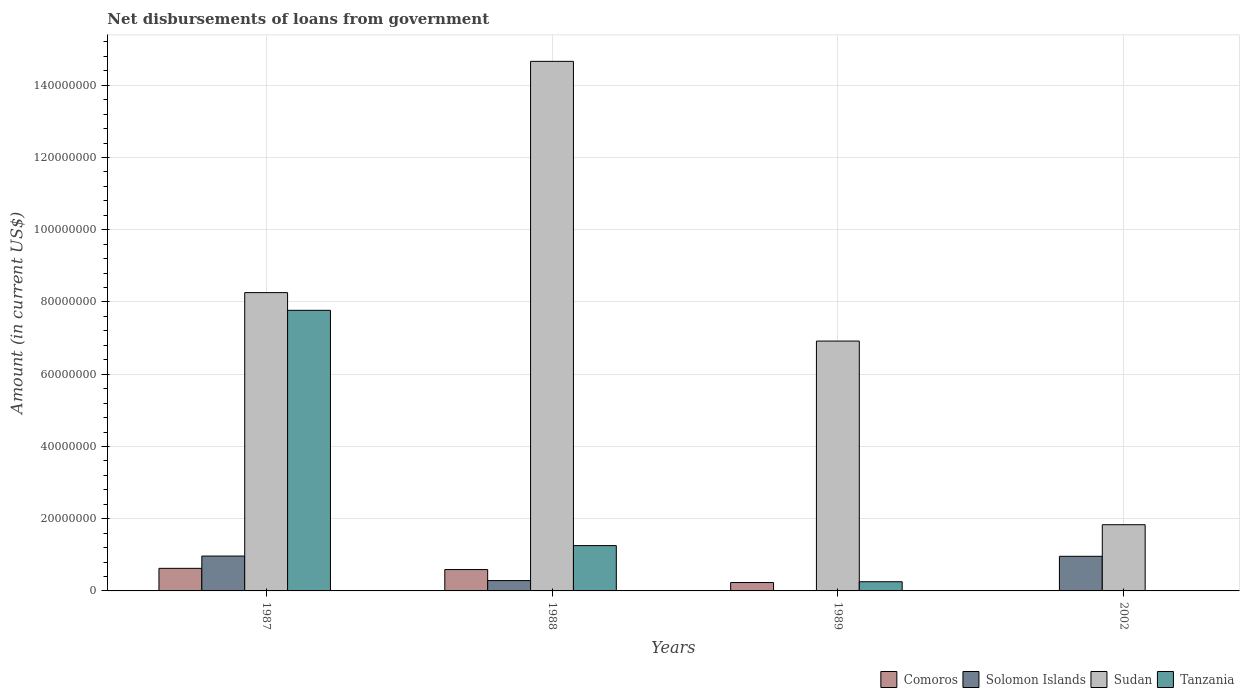How many different coloured bars are there?
Provide a succinct answer. 4. Are the number of bars on each tick of the X-axis equal?
Ensure brevity in your answer.  No. In how many cases, is the number of bars for a given year not equal to the number of legend labels?
Ensure brevity in your answer.  2. What is the amount of loan disbursed from government in Sudan in 1989?
Your answer should be compact. 6.92e+07. Across all years, what is the maximum amount of loan disbursed from government in Solomon Islands?
Give a very brief answer. 9.65e+06. Across all years, what is the minimum amount of loan disbursed from government in Tanzania?
Give a very brief answer. 0. In which year was the amount of loan disbursed from government in Sudan maximum?
Offer a very short reply. 1988. What is the total amount of loan disbursed from government in Comoros in the graph?
Give a very brief answer. 1.45e+07. What is the difference between the amount of loan disbursed from government in Sudan in 1987 and that in 1988?
Your response must be concise. -6.40e+07. What is the difference between the amount of loan disbursed from government in Sudan in 1987 and the amount of loan disbursed from government in Solomon Islands in 2002?
Give a very brief answer. 7.30e+07. What is the average amount of loan disbursed from government in Comoros per year?
Offer a very short reply. 3.62e+06. In the year 1987, what is the difference between the amount of loan disbursed from government in Comoros and amount of loan disbursed from government in Solomon Islands?
Make the answer very short. -3.40e+06. In how many years, is the amount of loan disbursed from government in Solomon Islands greater than 112000000 US$?
Give a very brief answer. 0. What is the ratio of the amount of loan disbursed from government in Tanzania in 1987 to that in 1989?
Your answer should be compact. 30.58. What is the difference between the highest and the second highest amount of loan disbursed from government in Sudan?
Make the answer very short. 6.40e+07. What is the difference between the highest and the lowest amount of loan disbursed from government in Tanzania?
Provide a succinct answer. 7.77e+07. In how many years, is the amount of loan disbursed from government in Tanzania greater than the average amount of loan disbursed from government in Tanzania taken over all years?
Offer a very short reply. 1. Is it the case that in every year, the sum of the amount of loan disbursed from government in Tanzania and amount of loan disbursed from government in Sudan is greater than the sum of amount of loan disbursed from government in Solomon Islands and amount of loan disbursed from government in Comoros?
Give a very brief answer. Yes. What is the difference between two consecutive major ticks on the Y-axis?
Offer a terse response. 2.00e+07. Where does the legend appear in the graph?
Provide a succinct answer. Bottom right. How are the legend labels stacked?
Give a very brief answer. Horizontal. What is the title of the graph?
Ensure brevity in your answer.  Net disbursements of loans from government. Does "United Arab Emirates" appear as one of the legend labels in the graph?
Provide a succinct answer. No. What is the label or title of the Y-axis?
Give a very brief answer. Amount (in current US$). What is the Amount (in current US$) in Comoros in 1987?
Your answer should be very brief. 6.25e+06. What is the Amount (in current US$) of Solomon Islands in 1987?
Your answer should be very brief. 9.65e+06. What is the Amount (in current US$) of Sudan in 1987?
Your response must be concise. 8.26e+07. What is the Amount (in current US$) of Tanzania in 1987?
Make the answer very short. 7.77e+07. What is the Amount (in current US$) in Comoros in 1988?
Provide a succinct answer. 5.91e+06. What is the Amount (in current US$) of Solomon Islands in 1988?
Offer a very short reply. 2.86e+06. What is the Amount (in current US$) in Sudan in 1988?
Provide a succinct answer. 1.47e+08. What is the Amount (in current US$) of Tanzania in 1988?
Offer a very short reply. 1.25e+07. What is the Amount (in current US$) in Comoros in 1989?
Give a very brief answer. 2.32e+06. What is the Amount (in current US$) in Sudan in 1989?
Offer a very short reply. 6.92e+07. What is the Amount (in current US$) of Tanzania in 1989?
Your answer should be very brief. 2.54e+06. What is the Amount (in current US$) of Comoros in 2002?
Offer a very short reply. 0. What is the Amount (in current US$) in Solomon Islands in 2002?
Keep it short and to the point. 9.58e+06. What is the Amount (in current US$) of Sudan in 2002?
Offer a very short reply. 1.83e+07. What is the Amount (in current US$) of Tanzania in 2002?
Give a very brief answer. 0. Across all years, what is the maximum Amount (in current US$) of Comoros?
Your answer should be compact. 6.25e+06. Across all years, what is the maximum Amount (in current US$) of Solomon Islands?
Keep it short and to the point. 9.65e+06. Across all years, what is the maximum Amount (in current US$) in Sudan?
Give a very brief answer. 1.47e+08. Across all years, what is the maximum Amount (in current US$) in Tanzania?
Provide a succinct answer. 7.77e+07. Across all years, what is the minimum Amount (in current US$) in Solomon Islands?
Provide a short and direct response. 0. Across all years, what is the minimum Amount (in current US$) of Sudan?
Provide a short and direct response. 1.83e+07. Across all years, what is the minimum Amount (in current US$) in Tanzania?
Offer a very short reply. 0. What is the total Amount (in current US$) of Comoros in the graph?
Ensure brevity in your answer.  1.45e+07. What is the total Amount (in current US$) in Solomon Islands in the graph?
Offer a very short reply. 2.21e+07. What is the total Amount (in current US$) in Sudan in the graph?
Your answer should be compact. 3.17e+08. What is the total Amount (in current US$) of Tanzania in the graph?
Keep it short and to the point. 9.28e+07. What is the difference between the Amount (in current US$) of Comoros in 1987 and that in 1988?
Give a very brief answer. 3.39e+05. What is the difference between the Amount (in current US$) of Solomon Islands in 1987 and that in 1988?
Your answer should be very brief. 6.79e+06. What is the difference between the Amount (in current US$) in Sudan in 1987 and that in 1988?
Provide a short and direct response. -6.40e+07. What is the difference between the Amount (in current US$) in Tanzania in 1987 and that in 1988?
Provide a short and direct response. 6.51e+07. What is the difference between the Amount (in current US$) of Comoros in 1987 and that in 1989?
Keep it short and to the point. 3.93e+06. What is the difference between the Amount (in current US$) of Sudan in 1987 and that in 1989?
Offer a very short reply. 1.34e+07. What is the difference between the Amount (in current US$) in Tanzania in 1987 and that in 1989?
Give a very brief answer. 7.52e+07. What is the difference between the Amount (in current US$) of Solomon Islands in 1987 and that in 2002?
Provide a succinct answer. 6.90e+04. What is the difference between the Amount (in current US$) in Sudan in 1987 and that in 2002?
Ensure brevity in your answer.  6.43e+07. What is the difference between the Amount (in current US$) in Comoros in 1988 and that in 1989?
Your answer should be very brief. 3.59e+06. What is the difference between the Amount (in current US$) of Sudan in 1988 and that in 1989?
Keep it short and to the point. 7.74e+07. What is the difference between the Amount (in current US$) in Tanzania in 1988 and that in 1989?
Keep it short and to the point. 1.00e+07. What is the difference between the Amount (in current US$) of Solomon Islands in 1988 and that in 2002?
Offer a very short reply. -6.72e+06. What is the difference between the Amount (in current US$) of Sudan in 1988 and that in 2002?
Provide a succinct answer. 1.28e+08. What is the difference between the Amount (in current US$) in Sudan in 1989 and that in 2002?
Your response must be concise. 5.08e+07. What is the difference between the Amount (in current US$) of Comoros in 1987 and the Amount (in current US$) of Solomon Islands in 1988?
Offer a very short reply. 3.39e+06. What is the difference between the Amount (in current US$) of Comoros in 1987 and the Amount (in current US$) of Sudan in 1988?
Provide a succinct answer. -1.40e+08. What is the difference between the Amount (in current US$) of Comoros in 1987 and the Amount (in current US$) of Tanzania in 1988?
Your answer should be very brief. -6.30e+06. What is the difference between the Amount (in current US$) in Solomon Islands in 1987 and the Amount (in current US$) in Sudan in 1988?
Your answer should be very brief. -1.37e+08. What is the difference between the Amount (in current US$) of Solomon Islands in 1987 and the Amount (in current US$) of Tanzania in 1988?
Provide a succinct answer. -2.90e+06. What is the difference between the Amount (in current US$) in Sudan in 1987 and the Amount (in current US$) in Tanzania in 1988?
Provide a succinct answer. 7.00e+07. What is the difference between the Amount (in current US$) of Comoros in 1987 and the Amount (in current US$) of Sudan in 1989?
Give a very brief answer. -6.29e+07. What is the difference between the Amount (in current US$) in Comoros in 1987 and the Amount (in current US$) in Tanzania in 1989?
Your response must be concise. 3.71e+06. What is the difference between the Amount (in current US$) of Solomon Islands in 1987 and the Amount (in current US$) of Sudan in 1989?
Keep it short and to the point. -5.95e+07. What is the difference between the Amount (in current US$) in Solomon Islands in 1987 and the Amount (in current US$) in Tanzania in 1989?
Offer a terse response. 7.11e+06. What is the difference between the Amount (in current US$) of Sudan in 1987 and the Amount (in current US$) of Tanzania in 1989?
Your answer should be very brief. 8.01e+07. What is the difference between the Amount (in current US$) of Comoros in 1987 and the Amount (in current US$) of Solomon Islands in 2002?
Your answer should be compact. -3.33e+06. What is the difference between the Amount (in current US$) of Comoros in 1987 and the Amount (in current US$) of Sudan in 2002?
Your answer should be very brief. -1.21e+07. What is the difference between the Amount (in current US$) of Solomon Islands in 1987 and the Amount (in current US$) of Sudan in 2002?
Keep it short and to the point. -8.68e+06. What is the difference between the Amount (in current US$) in Comoros in 1988 and the Amount (in current US$) in Sudan in 1989?
Keep it short and to the point. -6.33e+07. What is the difference between the Amount (in current US$) of Comoros in 1988 and the Amount (in current US$) of Tanzania in 1989?
Offer a very short reply. 3.37e+06. What is the difference between the Amount (in current US$) of Solomon Islands in 1988 and the Amount (in current US$) of Sudan in 1989?
Keep it short and to the point. -6.63e+07. What is the difference between the Amount (in current US$) of Solomon Islands in 1988 and the Amount (in current US$) of Tanzania in 1989?
Keep it short and to the point. 3.22e+05. What is the difference between the Amount (in current US$) in Sudan in 1988 and the Amount (in current US$) in Tanzania in 1989?
Ensure brevity in your answer.  1.44e+08. What is the difference between the Amount (in current US$) of Comoros in 1988 and the Amount (in current US$) of Solomon Islands in 2002?
Offer a terse response. -3.67e+06. What is the difference between the Amount (in current US$) in Comoros in 1988 and the Amount (in current US$) in Sudan in 2002?
Your response must be concise. -1.24e+07. What is the difference between the Amount (in current US$) in Solomon Islands in 1988 and the Amount (in current US$) in Sudan in 2002?
Give a very brief answer. -1.55e+07. What is the difference between the Amount (in current US$) in Comoros in 1989 and the Amount (in current US$) in Solomon Islands in 2002?
Keep it short and to the point. -7.26e+06. What is the difference between the Amount (in current US$) in Comoros in 1989 and the Amount (in current US$) in Sudan in 2002?
Keep it short and to the point. -1.60e+07. What is the average Amount (in current US$) in Comoros per year?
Give a very brief answer. 3.62e+06. What is the average Amount (in current US$) in Solomon Islands per year?
Offer a very short reply. 5.52e+06. What is the average Amount (in current US$) of Sudan per year?
Make the answer very short. 7.92e+07. What is the average Amount (in current US$) in Tanzania per year?
Keep it short and to the point. 2.32e+07. In the year 1987, what is the difference between the Amount (in current US$) of Comoros and Amount (in current US$) of Solomon Islands?
Give a very brief answer. -3.40e+06. In the year 1987, what is the difference between the Amount (in current US$) of Comoros and Amount (in current US$) of Sudan?
Keep it short and to the point. -7.63e+07. In the year 1987, what is the difference between the Amount (in current US$) of Comoros and Amount (in current US$) of Tanzania?
Ensure brevity in your answer.  -7.14e+07. In the year 1987, what is the difference between the Amount (in current US$) of Solomon Islands and Amount (in current US$) of Sudan?
Offer a terse response. -7.29e+07. In the year 1987, what is the difference between the Amount (in current US$) in Solomon Islands and Amount (in current US$) in Tanzania?
Provide a short and direct response. -6.80e+07. In the year 1987, what is the difference between the Amount (in current US$) in Sudan and Amount (in current US$) in Tanzania?
Offer a very short reply. 4.90e+06. In the year 1988, what is the difference between the Amount (in current US$) of Comoros and Amount (in current US$) of Solomon Islands?
Keep it short and to the point. 3.05e+06. In the year 1988, what is the difference between the Amount (in current US$) of Comoros and Amount (in current US$) of Sudan?
Offer a very short reply. -1.41e+08. In the year 1988, what is the difference between the Amount (in current US$) in Comoros and Amount (in current US$) in Tanzania?
Your answer should be compact. -6.64e+06. In the year 1988, what is the difference between the Amount (in current US$) in Solomon Islands and Amount (in current US$) in Sudan?
Offer a terse response. -1.44e+08. In the year 1988, what is the difference between the Amount (in current US$) in Solomon Islands and Amount (in current US$) in Tanzania?
Your answer should be very brief. -9.68e+06. In the year 1988, what is the difference between the Amount (in current US$) in Sudan and Amount (in current US$) in Tanzania?
Provide a short and direct response. 1.34e+08. In the year 1989, what is the difference between the Amount (in current US$) of Comoros and Amount (in current US$) of Sudan?
Keep it short and to the point. -6.69e+07. In the year 1989, what is the difference between the Amount (in current US$) in Comoros and Amount (in current US$) in Tanzania?
Make the answer very short. -2.22e+05. In the year 1989, what is the difference between the Amount (in current US$) of Sudan and Amount (in current US$) of Tanzania?
Your response must be concise. 6.66e+07. In the year 2002, what is the difference between the Amount (in current US$) in Solomon Islands and Amount (in current US$) in Sudan?
Ensure brevity in your answer.  -8.75e+06. What is the ratio of the Amount (in current US$) of Comoros in 1987 to that in 1988?
Your answer should be compact. 1.06. What is the ratio of the Amount (in current US$) of Solomon Islands in 1987 to that in 1988?
Provide a short and direct response. 3.37. What is the ratio of the Amount (in current US$) in Sudan in 1987 to that in 1988?
Your response must be concise. 0.56. What is the ratio of the Amount (in current US$) in Tanzania in 1987 to that in 1988?
Your response must be concise. 6.19. What is the ratio of the Amount (in current US$) of Comoros in 1987 to that in 1989?
Ensure brevity in your answer.  2.7. What is the ratio of the Amount (in current US$) in Sudan in 1987 to that in 1989?
Give a very brief answer. 1.19. What is the ratio of the Amount (in current US$) in Tanzania in 1987 to that in 1989?
Give a very brief answer. 30.58. What is the ratio of the Amount (in current US$) in Solomon Islands in 1987 to that in 2002?
Ensure brevity in your answer.  1.01. What is the ratio of the Amount (in current US$) in Sudan in 1987 to that in 2002?
Your response must be concise. 4.51. What is the ratio of the Amount (in current US$) of Comoros in 1988 to that in 1989?
Your answer should be very brief. 2.55. What is the ratio of the Amount (in current US$) of Sudan in 1988 to that in 1989?
Your response must be concise. 2.12. What is the ratio of the Amount (in current US$) in Tanzania in 1988 to that in 1989?
Make the answer very short. 4.94. What is the ratio of the Amount (in current US$) in Solomon Islands in 1988 to that in 2002?
Your answer should be very brief. 0.3. What is the ratio of the Amount (in current US$) in Sudan in 1988 to that in 2002?
Your answer should be very brief. 8. What is the ratio of the Amount (in current US$) in Sudan in 1989 to that in 2002?
Your answer should be very brief. 3.77. What is the difference between the highest and the second highest Amount (in current US$) of Comoros?
Your answer should be compact. 3.39e+05. What is the difference between the highest and the second highest Amount (in current US$) of Solomon Islands?
Offer a terse response. 6.90e+04. What is the difference between the highest and the second highest Amount (in current US$) of Sudan?
Provide a short and direct response. 6.40e+07. What is the difference between the highest and the second highest Amount (in current US$) in Tanzania?
Offer a terse response. 6.51e+07. What is the difference between the highest and the lowest Amount (in current US$) in Comoros?
Provide a short and direct response. 6.25e+06. What is the difference between the highest and the lowest Amount (in current US$) in Solomon Islands?
Your answer should be very brief. 9.65e+06. What is the difference between the highest and the lowest Amount (in current US$) in Sudan?
Offer a very short reply. 1.28e+08. What is the difference between the highest and the lowest Amount (in current US$) of Tanzania?
Your answer should be compact. 7.77e+07. 